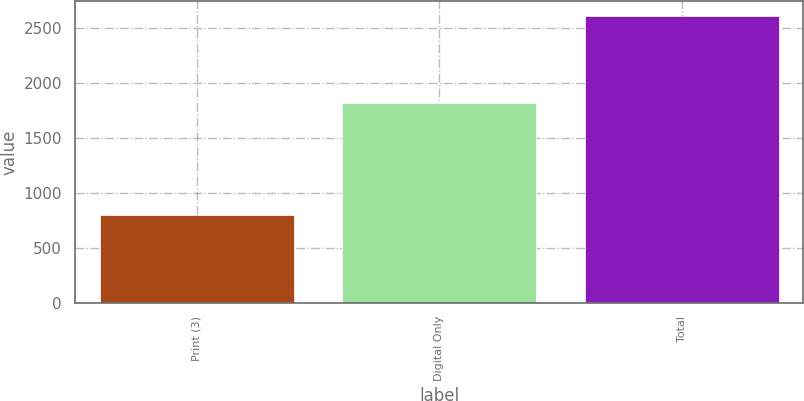<chart> <loc_0><loc_0><loc_500><loc_500><bar_chart><fcel>Print (3)<fcel>Digital Only<fcel>Total<nl><fcel>799<fcel>1818<fcel>2617<nl></chart> 